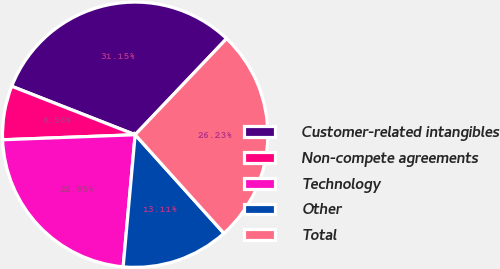<chart> <loc_0><loc_0><loc_500><loc_500><pie_chart><fcel>Customer-related intangibles<fcel>Non-compete agreements<fcel>Technology<fcel>Other<fcel>Total<nl><fcel>31.15%<fcel>6.56%<fcel>22.95%<fcel>13.11%<fcel>26.23%<nl></chart> 